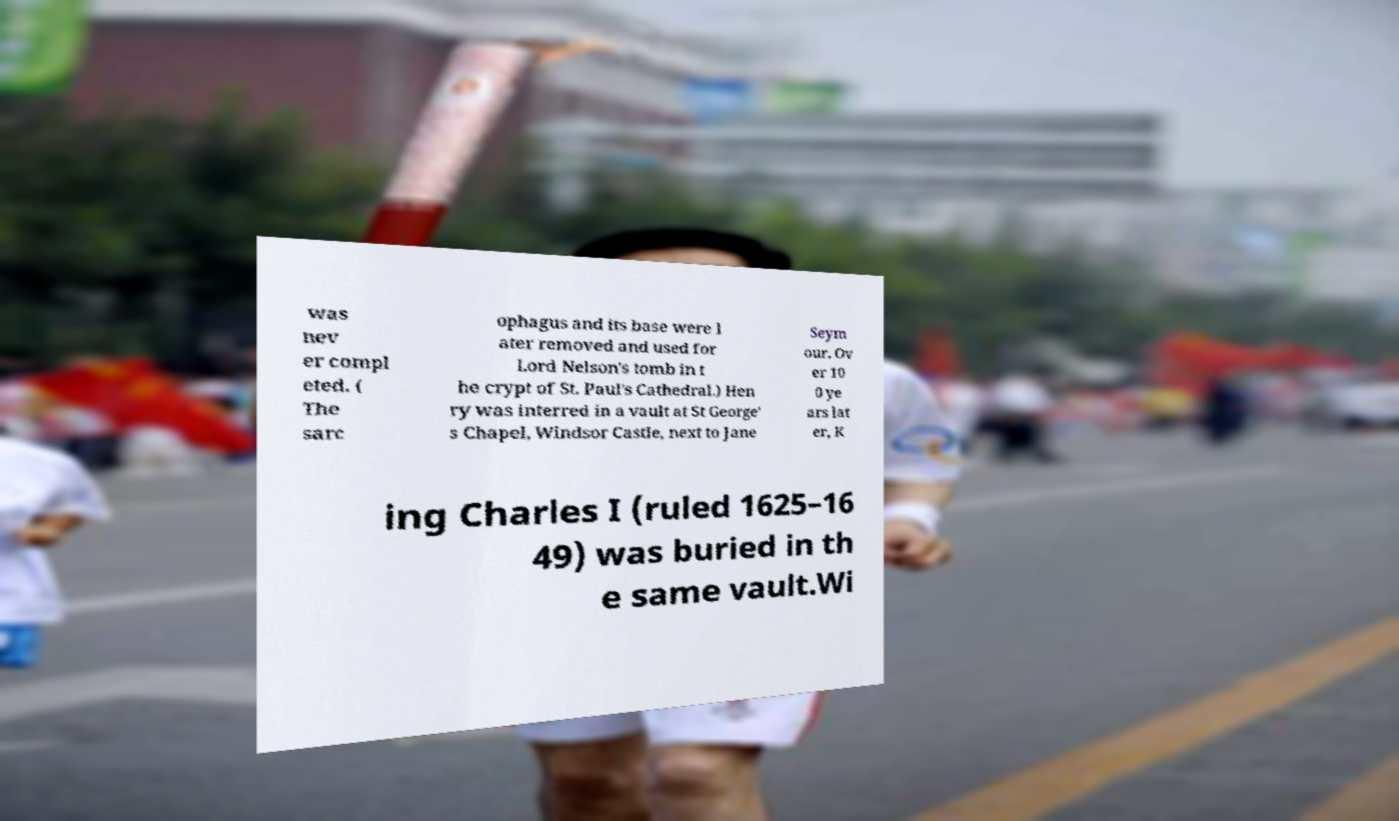Can you accurately transcribe the text from the provided image for me? was nev er compl eted. ( The sarc ophagus and its base were l ater removed and used for Lord Nelson's tomb in t he crypt of St. Paul's Cathedral.) Hen ry was interred in a vault at St George' s Chapel, Windsor Castle, next to Jane Seym our. Ov er 10 0 ye ars lat er, K ing Charles I (ruled 1625–16 49) was buried in th e same vault.Wi 